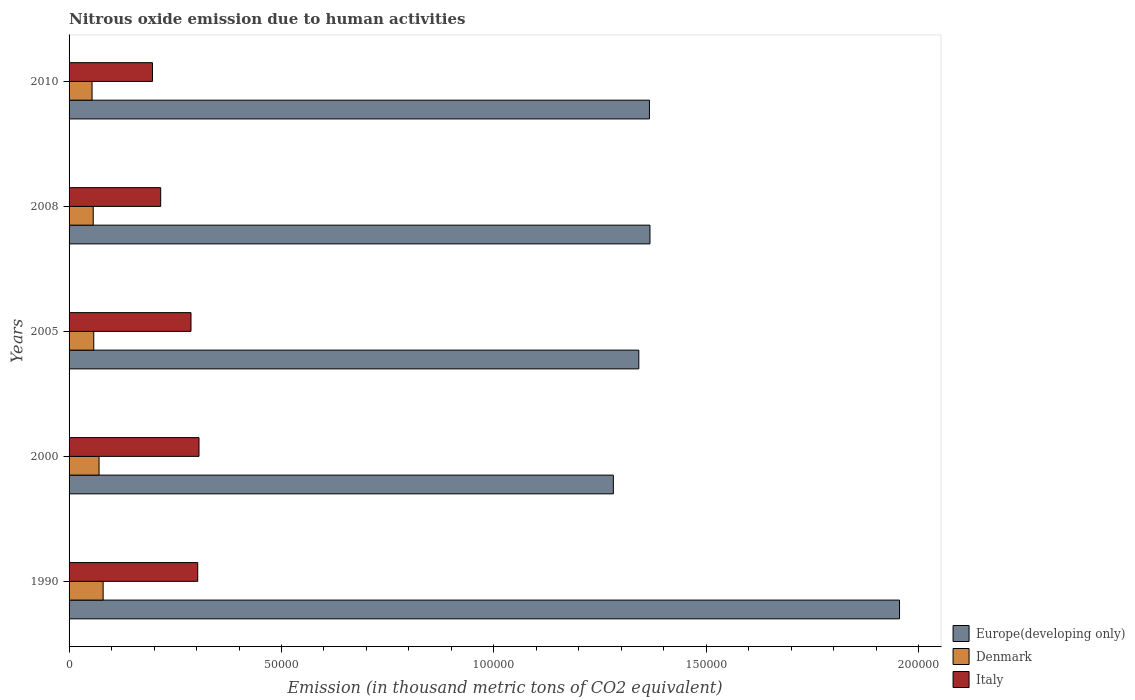How many groups of bars are there?
Your answer should be compact. 5. Are the number of bars per tick equal to the number of legend labels?
Keep it short and to the point. Yes. What is the label of the 2nd group of bars from the top?
Your answer should be compact. 2008. What is the amount of nitrous oxide emitted in Europe(developing only) in 2010?
Provide a short and direct response. 1.37e+05. Across all years, what is the maximum amount of nitrous oxide emitted in Denmark?
Provide a succinct answer. 8017.4. Across all years, what is the minimum amount of nitrous oxide emitted in Denmark?
Provide a short and direct response. 5410. What is the total amount of nitrous oxide emitted in Denmark in the graph?
Offer a very short reply. 3.20e+04. What is the difference between the amount of nitrous oxide emitted in Italy in 1990 and that in 2008?
Give a very brief answer. 8717. What is the difference between the amount of nitrous oxide emitted in Denmark in 2005 and the amount of nitrous oxide emitted in Italy in 2008?
Ensure brevity in your answer.  -1.58e+04. What is the average amount of nitrous oxide emitted in Italy per year?
Keep it short and to the point. 2.62e+04. In the year 2005, what is the difference between the amount of nitrous oxide emitted in Denmark and amount of nitrous oxide emitted in Italy?
Your answer should be compact. -2.29e+04. In how many years, is the amount of nitrous oxide emitted in Denmark greater than 110000 thousand metric tons?
Offer a terse response. 0. What is the ratio of the amount of nitrous oxide emitted in Italy in 2000 to that in 2005?
Offer a terse response. 1.07. Is the amount of nitrous oxide emitted in Italy in 1990 less than that in 2000?
Provide a short and direct response. Yes. Is the difference between the amount of nitrous oxide emitted in Denmark in 2008 and 2010 greater than the difference between the amount of nitrous oxide emitted in Italy in 2008 and 2010?
Give a very brief answer. No. What is the difference between the highest and the second highest amount of nitrous oxide emitted in Italy?
Give a very brief answer. 301.2. What is the difference between the highest and the lowest amount of nitrous oxide emitted in Italy?
Provide a short and direct response. 1.10e+04. In how many years, is the amount of nitrous oxide emitted in Italy greater than the average amount of nitrous oxide emitted in Italy taken over all years?
Your answer should be compact. 3. Is the sum of the amount of nitrous oxide emitted in Europe(developing only) in 1990 and 2000 greater than the maximum amount of nitrous oxide emitted in Denmark across all years?
Your response must be concise. Yes. What does the 1st bar from the bottom in 2008 represents?
Give a very brief answer. Europe(developing only). Is it the case that in every year, the sum of the amount of nitrous oxide emitted in Denmark and amount of nitrous oxide emitted in Italy is greater than the amount of nitrous oxide emitted in Europe(developing only)?
Keep it short and to the point. No. How many bars are there?
Offer a terse response. 15. Are all the bars in the graph horizontal?
Offer a very short reply. Yes. How many years are there in the graph?
Make the answer very short. 5. Where does the legend appear in the graph?
Give a very brief answer. Bottom right. How many legend labels are there?
Provide a succinct answer. 3. How are the legend labels stacked?
Give a very brief answer. Vertical. What is the title of the graph?
Give a very brief answer. Nitrous oxide emission due to human activities. Does "Suriname" appear as one of the legend labels in the graph?
Ensure brevity in your answer.  No. What is the label or title of the X-axis?
Your answer should be very brief. Emission (in thousand metric tons of CO2 equivalent). What is the label or title of the Y-axis?
Your response must be concise. Years. What is the Emission (in thousand metric tons of CO2 equivalent) in Europe(developing only) in 1990?
Offer a very short reply. 1.95e+05. What is the Emission (in thousand metric tons of CO2 equivalent) in Denmark in 1990?
Give a very brief answer. 8017.4. What is the Emission (in thousand metric tons of CO2 equivalent) in Italy in 1990?
Give a very brief answer. 3.03e+04. What is the Emission (in thousand metric tons of CO2 equivalent) in Europe(developing only) in 2000?
Provide a succinct answer. 1.28e+05. What is the Emission (in thousand metric tons of CO2 equivalent) in Denmark in 2000?
Ensure brevity in your answer.  7054.9. What is the Emission (in thousand metric tons of CO2 equivalent) in Italy in 2000?
Provide a succinct answer. 3.06e+04. What is the Emission (in thousand metric tons of CO2 equivalent) in Europe(developing only) in 2005?
Offer a very short reply. 1.34e+05. What is the Emission (in thousand metric tons of CO2 equivalent) of Denmark in 2005?
Make the answer very short. 5813.9. What is the Emission (in thousand metric tons of CO2 equivalent) in Italy in 2005?
Your answer should be very brief. 2.87e+04. What is the Emission (in thousand metric tons of CO2 equivalent) of Europe(developing only) in 2008?
Your answer should be very brief. 1.37e+05. What is the Emission (in thousand metric tons of CO2 equivalent) of Denmark in 2008?
Your answer should be very brief. 5688.2. What is the Emission (in thousand metric tons of CO2 equivalent) of Italy in 2008?
Your answer should be very brief. 2.16e+04. What is the Emission (in thousand metric tons of CO2 equivalent) of Europe(developing only) in 2010?
Offer a terse response. 1.37e+05. What is the Emission (in thousand metric tons of CO2 equivalent) of Denmark in 2010?
Your answer should be very brief. 5410. What is the Emission (in thousand metric tons of CO2 equivalent) of Italy in 2010?
Make the answer very short. 1.96e+04. Across all years, what is the maximum Emission (in thousand metric tons of CO2 equivalent) in Europe(developing only)?
Provide a succinct answer. 1.95e+05. Across all years, what is the maximum Emission (in thousand metric tons of CO2 equivalent) in Denmark?
Ensure brevity in your answer.  8017.4. Across all years, what is the maximum Emission (in thousand metric tons of CO2 equivalent) in Italy?
Provide a succinct answer. 3.06e+04. Across all years, what is the minimum Emission (in thousand metric tons of CO2 equivalent) in Europe(developing only)?
Provide a short and direct response. 1.28e+05. Across all years, what is the minimum Emission (in thousand metric tons of CO2 equivalent) in Denmark?
Your response must be concise. 5410. Across all years, what is the minimum Emission (in thousand metric tons of CO2 equivalent) in Italy?
Your answer should be very brief. 1.96e+04. What is the total Emission (in thousand metric tons of CO2 equivalent) in Europe(developing only) in the graph?
Your answer should be very brief. 7.31e+05. What is the total Emission (in thousand metric tons of CO2 equivalent) of Denmark in the graph?
Keep it short and to the point. 3.20e+04. What is the total Emission (in thousand metric tons of CO2 equivalent) of Italy in the graph?
Offer a terse response. 1.31e+05. What is the difference between the Emission (in thousand metric tons of CO2 equivalent) in Europe(developing only) in 1990 and that in 2000?
Your response must be concise. 6.74e+04. What is the difference between the Emission (in thousand metric tons of CO2 equivalent) in Denmark in 1990 and that in 2000?
Give a very brief answer. 962.5. What is the difference between the Emission (in thousand metric tons of CO2 equivalent) in Italy in 1990 and that in 2000?
Make the answer very short. -301.2. What is the difference between the Emission (in thousand metric tons of CO2 equivalent) in Europe(developing only) in 1990 and that in 2005?
Offer a very short reply. 6.14e+04. What is the difference between the Emission (in thousand metric tons of CO2 equivalent) of Denmark in 1990 and that in 2005?
Make the answer very short. 2203.5. What is the difference between the Emission (in thousand metric tons of CO2 equivalent) of Italy in 1990 and that in 2005?
Provide a short and direct response. 1584.9. What is the difference between the Emission (in thousand metric tons of CO2 equivalent) in Europe(developing only) in 1990 and that in 2008?
Keep it short and to the point. 5.87e+04. What is the difference between the Emission (in thousand metric tons of CO2 equivalent) in Denmark in 1990 and that in 2008?
Keep it short and to the point. 2329.2. What is the difference between the Emission (in thousand metric tons of CO2 equivalent) of Italy in 1990 and that in 2008?
Make the answer very short. 8717. What is the difference between the Emission (in thousand metric tons of CO2 equivalent) in Europe(developing only) in 1990 and that in 2010?
Offer a terse response. 5.89e+04. What is the difference between the Emission (in thousand metric tons of CO2 equivalent) of Denmark in 1990 and that in 2010?
Ensure brevity in your answer.  2607.4. What is the difference between the Emission (in thousand metric tons of CO2 equivalent) in Italy in 1990 and that in 2010?
Provide a succinct answer. 1.07e+04. What is the difference between the Emission (in thousand metric tons of CO2 equivalent) of Europe(developing only) in 2000 and that in 2005?
Provide a succinct answer. -5992.3. What is the difference between the Emission (in thousand metric tons of CO2 equivalent) in Denmark in 2000 and that in 2005?
Your answer should be very brief. 1241. What is the difference between the Emission (in thousand metric tons of CO2 equivalent) of Italy in 2000 and that in 2005?
Provide a succinct answer. 1886.1. What is the difference between the Emission (in thousand metric tons of CO2 equivalent) in Europe(developing only) in 2000 and that in 2008?
Your answer should be very brief. -8618.7. What is the difference between the Emission (in thousand metric tons of CO2 equivalent) of Denmark in 2000 and that in 2008?
Keep it short and to the point. 1366.7. What is the difference between the Emission (in thousand metric tons of CO2 equivalent) in Italy in 2000 and that in 2008?
Offer a terse response. 9018.2. What is the difference between the Emission (in thousand metric tons of CO2 equivalent) in Europe(developing only) in 2000 and that in 2010?
Offer a very short reply. -8495.7. What is the difference between the Emission (in thousand metric tons of CO2 equivalent) in Denmark in 2000 and that in 2010?
Make the answer very short. 1644.9. What is the difference between the Emission (in thousand metric tons of CO2 equivalent) in Italy in 2000 and that in 2010?
Offer a terse response. 1.10e+04. What is the difference between the Emission (in thousand metric tons of CO2 equivalent) of Europe(developing only) in 2005 and that in 2008?
Offer a very short reply. -2626.4. What is the difference between the Emission (in thousand metric tons of CO2 equivalent) in Denmark in 2005 and that in 2008?
Make the answer very short. 125.7. What is the difference between the Emission (in thousand metric tons of CO2 equivalent) in Italy in 2005 and that in 2008?
Your answer should be very brief. 7132.1. What is the difference between the Emission (in thousand metric tons of CO2 equivalent) in Europe(developing only) in 2005 and that in 2010?
Keep it short and to the point. -2503.4. What is the difference between the Emission (in thousand metric tons of CO2 equivalent) in Denmark in 2005 and that in 2010?
Make the answer very short. 403.9. What is the difference between the Emission (in thousand metric tons of CO2 equivalent) in Italy in 2005 and that in 2010?
Your answer should be compact. 9065.9. What is the difference between the Emission (in thousand metric tons of CO2 equivalent) in Europe(developing only) in 2008 and that in 2010?
Provide a succinct answer. 123. What is the difference between the Emission (in thousand metric tons of CO2 equivalent) in Denmark in 2008 and that in 2010?
Your response must be concise. 278.2. What is the difference between the Emission (in thousand metric tons of CO2 equivalent) of Italy in 2008 and that in 2010?
Provide a succinct answer. 1933.8. What is the difference between the Emission (in thousand metric tons of CO2 equivalent) in Europe(developing only) in 1990 and the Emission (in thousand metric tons of CO2 equivalent) in Denmark in 2000?
Offer a very short reply. 1.88e+05. What is the difference between the Emission (in thousand metric tons of CO2 equivalent) in Europe(developing only) in 1990 and the Emission (in thousand metric tons of CO2 equivalent) in Italy in 2000?
Offer a terse response. 1.65e+05. What is the difference between the Emission (in thousand metric tons of CO2 equivalent) in Denmark in 1990 and the Emission (in thousand metric tons of CO2 equivalent) in Italy in 2000?
Your answer should be compact. -2.26e+04. What is the difference between the Emission (in thousand metric tons of CO2 equivalent) in Europe(developing only) in 1990 and the Emission (in thousand metric tons of CO2 equivalent) in Denmark in 2005?
Provide a succinct answer. 1.90e+05. What is the difference between the Emission (in thousand metric tons of CO2 equivalent) of Europe(developing only) in 1990 and the Emission (in thousand metric tons of CO2 equivalent) of Italy in 2005?
Offer a very short reply. 1.67e+05. What is the difference between the Emission (in thousand metric tons of CO2 equivalent) in Denmark in 1990 and the Emission (in thousand metric tons of CO2 equivalent) in Italy in 2005?
Provide a succinct answer. -2.07e+04. What is the difference between the Emission (in thousand metric tons of CO2 equivalent) of Europe(developing only) in 1990 and the Emission (in thousand metric tons of CO2 equivalent) of Denmark in 2008?
Offer a terse response. 1.90e+05. What is the difference between the Emission (in thousand metric tons of CO2 equivalent) of Europe(developing only) in 1990 and the Emission (in thousand metric tons of CO2 equivalent) of Italy in 2008?
Ensure brevity in your answer.  1.74e+05. What is the difference between the Emission (in thousand metric tons of CO2 equivalent) in Denmark in 1990 and the Emission (in thousand metric tons of CO2 equivalent) in Italy in 2008?
Offer a very short reply. -1.35e+04. What is the difference between the Emission (in thousand metric tons of CO2 equivalent) in Europe(developing only) in 1990 and the Emission (in thousand metric tons of CO2 equivalent) in Denmark in 2010?
Give a very brief answer. 1.90e+05. What is the difference between the Emission (in thousand metric tons of CO2 equivalent) of Europe(developing only) in 1990 and the Emission (in thousand metric tons of CO2 equivalent) of Italy in 2010?
Give a very brief answer. 1.76e+05. What is the difference between the Emission (in thousand metric tons of CO2 equivalent) in Denmark in 1990 and the Emission (in thousand metric tons of CO2 equivalent) in Italy in 2010?
Keep it short and to the point. -1.16e+04. What is the difference between the Emission (in thousand metric tons of CO2 equivalent) in Europe(developing only) in 2000 and the Emission (in thousand metric tons of CO2 equivalent) in Denmark in 2005?
Offer a terse response. 1.22e+05. What is the difference between the Emission (in thousand metric tons of CO2 equivalent) in Europe(developing only) in 2000 and the Emission (in thousand metric tons of CO2 equivalent) in Italy in 2005?
Make the answer very short. 9.94e+04. What is the difference between the Emission (in thousand metric tons of CO2 equivalent) in Denmark in 2000 and the Emission (in thousand metric tons of CO2 equivalent) in Italy in 2005?
Your response must be concise. -2.16e+04. What is the difference between the Emission (in thousand metric tons of CO2 equivalent) of Europe(developing only) in 2000 and the Emission (in thousand metric tons of CO2 equivalent) of Denmark in 2008?
Your response must be concise. 1.22e+05. What is the difference between the Emission (in thousand metric tons of CO2 equivalent) in Europe(developing only) in 2000 and the Emission (in thousand metric tons of CO2 equivalent) in Italy in 2008?
Make the answer very short. 1.07e+05. What is the difference between the Emission (in thousand metric tons of CO2 equivalent) in Denmark in 2000 and the Emission (in thousand metric tons of CO2 equivalent) in Italy in 2008?
Your response must be concise. -1.45e+04. What is the difference between the Emission (in thousand metric tons of CO2 equivalent) in Europe(developing only) in 2000 and the Emission (in thousand metric tons of CO2 equivalent) in Denmark in 2010?
Your response must be concise. 1.23e+05. What is the difference between the Emission (in thousand metric tons of CO2 equivalent) of Europe(developing only) in 2000 and the Emission (in thousand metric tons of CO2 equivalent) of Italy in 2010?
Keep it short and to the point. 1.08e+05. What is the difference between the Emission (in thousand metric tons of CO2 equivalent) of Denmark in 2000 and the Emission (in thousand metric tons of CO2 equivalent) of Italy in 2010?
Give a very brief answer. -1.26e+04. What is the difference between the Emission (in thousand metric tons of CO2 equivalent) in Europe(developing only) in 2005 and the Emission (in thousand metric tons of CO2 equivalent) in Denmark in 2008?
Provide a succinct answer. 1.28e+05. What is the difference between the Emission (in thousand metric tons of CO2 equivalent) in Europe(developing only) in 2005 and the Emission (in thousand metric tons of CO2 equivalent) in Italy in 2008?
Provide a succinct answer. 1.13e+05. What is the difference between the Emission (in thousand metric tons of CO2 equivalent) of Denmark in 2005 and the Emission (in thousand metric tons of CO2 equivalent) of Italy in 2008?
Provide a succinct answer. -1.58e+04. What is the difference between the Emission (in thousand metric tons of CO2 equivalent) in Europe(developing only) in 2005 and the Emission (in thousand metric tons of CO2 equivalent) in Denmark in 2010?
Offer a terse response. 1.29e+05. What is the difference between the Emission (in thousand metric tons of CO2 equivalent) of Europe(developing only) in 2005 and the Emission (in thousand metric tons of CO2 equivalent) of Italy in 2010?
Make the answer very short. 1.14e+05. What is the difference between the Emission (in thousand metric tons of CO2 equivalent) in Denmark in 2005 and the Emission (in thousand metric tons of CO2 equivalent) in Italy in 2010?
Offer a very short reply. -1.38e+04. What is the difference between the Emission (in thousand metric tons of CO2 equivalent) in Europe(developing only) in 2008 and the Emission (in thousand metric tons of CO2 equivalent) in Denmark in 2010?
Make the answer very short. 1.31e+05. What is the difference between the Emission (in thousand metric tons of CO2 equivalent) of Europe(developing only) in 2008 and the Emission (in thousand metric tons of CO2 equivalent) of Italy in 2010?
Your answer should be compact. 1.17e+05. What is the difference between the Emission (in thousand metric tons of CO2 equivalent) of Denmark in 2008 and the Emission (in thousand metric tons of CO2 equivalent) of Italy in 2010?
Your response must be concise. -1.39e+04. What is the average Emission (in thousand metric tons of CO2 equivalent) of Europe(developing only) per year?
Make the answer very short. 1.46e+05. What is the average Emission (in thousand metric tons of CO2 equivalent) in Denmark per year?
Keep it short and to the point. 6396.88. What is the average Emission (in thousand metric tons of CO2 equivalent) in Italy per year?
Make the answer very short. 2.62e+04. In the year 1990, what is the difference between the Emission (in thousand metric tons of CO2 equivalent) of Europe(developing only) and Emission (in thousand metric tons of CO2 equivalent) of Denmark?
Your response must be concise. 1.87e+05. In the year 1990, what is the difference between the Emission (in thousand metric tons of CO2 equivalent) of Europe(developing only) and Emission (in thousand metric tons of CO2 equivalent) of Italy?
Your response must be concise. 1.65e+05. In the year 1990, what is the difference between the Emission (in thousand metric tons of CO2 equivalent) of Denmark and Emission (in thousand metric tons of CO2 equivalent) of Italy?
Provide a succinct answer. -2.23e+04. In the year 2000, what is the difference between the Emission (in thousand metric tons of CO2 equivalent) of Europe(developing only) and Emission (in thousand metric tons of CO2 equivalent) of Denmark?
Ensure brevity in your answer.  1.21e+05. In the year 2000, what is the difference between the Emission (in thousand metric tons of CO2 equivalent) in Europe(developing only) and Emission (in thousand metric tons of CO2 equivalent) in Italy?
Give a very brief answer. 9.75e+04. In the year 2000, what is the difference between the Emission (in thousand metric tons of CO2 equivalent) in Denmark and Emission (in thousand metric tons of CO2 equivalent) in Italy?
Make the answer very short. -2.35e+04. In the year 2005, what is the difference between the Emission (in thousand metric tons of CO2 equivalent) in Europe(developing only) and Emission (in thousand metric tons of CO2 equivalent) in Denmark?
Provide a succinct answer. 1.28e+05. In the year 2005, what is the difference between the Emission (in thousand metric tons of CO2 equivalent) in Europe(developing only) and Emission (in thousand metric tons of CO2 equivalent) in Italy?
Give a very brief answer. 1.05e+05. In the year 2005, what is the difference between the Emission (in thousand metric tons of CO2 equivalent) of Denmark and Emission (in thousand metric tons of CO2 equivalent) of Italy?
Provide a short and direct response. -2.29e+04. In the year 2008, what is the difference between the Emission (in thousand metric tons of CO2 equivalent) of Europe(developing only) and Emission (in thousand metric tons of CO2 equivalent) of Denmark?
Keep it short and to the point. 1.31e+05. In the year 2008, what is the difference between the Emission (in thousand metric tons of CO2 equivalent) in Europe(developing only) and Emission (in thousand metric tons of CO2 equivalent) in Italy?
Your answer should be compact. 1.15e+05. In the year 2008, what is the difference between the Emission (in thousand metric tons of CO2 equivalent) in Denmark and Emission (in thousand metric tons of CO2 equivalent) in Italy?
Offer a very short reply. -1.59e+04. In the year 2010, what is the difference between the Emission (in thousand metric tons of CO2 equivalent) of Europe(developing only) and Emission (in thousand metric tons of CO2 equivalent) of Denmark?
Your answer should be compact. 1.31e+05. In the year 2010, what is the difference between the Emission (in thousand metric tons of CO2 equivalent) in Europe(developing only) and Emission (in thousand metric tons of CO2 equivalent) in Italy?
Your answer should be compact. 1.17e+05. In the year 2010, what is the difference between the Emission (in thousand metric tons of CO2 equivalent) of Denmark and Emission (in thousand metric tons of CO2 equivalent) of Italy?
Your response must be concise. -1.42e+04. What is the ratio of the Emission (in thousand metric tons of CO2 equivalent) of Europe(developing only) in 1990 to that in 2000?
Offer a very short reply. 1.53. What is the ratio of the Emission (in thousand metric tons of CO2 equivalent) of Denmark in 1990 to that in 2000?
Your answer should be compact. 1.14. What is the ratio of the Emission (in thousand metric tons of CO2 equivalent) in Italy in 1990 to that in 2000?
Your response must be concise. 0.99. What is the ratio of the Emission (in thousand metric tons of CO2 equivalent) in Europe(developing only) in 1990 to that in 2005?
Your response must be concise. 1.46. What is the ratio of the Emission (in thousand metric tons of CO2 equivalent) of Denmark in 1990 to that in 2005?
Provide a short and direct response. 1.38. What is the ratio of the Emission (in thousand metric tons of CO2 equivalent) in Italy in 1990 to that in 2005?
Provide a succinct answer. 1.06. What is the ratio of the Emission (in thousand metric tons of CO2 equivalent) in Europe(developing only) in 1990 to that in 2008?
Offer a very short reply. 1.43. What is the ratio of the Emission (in thousand metric tons of CO2 equivalent) of Denmark in 1990 to that in 2008?
Provide a short and direct response. 1.41. What is the ratio of the Emission (in thousand metric tons of CO2 equivalent) of Italy in 1990 to that in 2008?
Your response must be concise. 1.4. What is the ratio of the Emission (in thousand metric tons of CO2 equivalent) in Europe(developing only) in 1990 to that in 2010?
Offer a terse response. 1.43. What is the ratio of the Emission (in thousand metric tons of CO2 equivalent) in Denmark in 1990 to that in 2010?
Your answer should be compact. 1.48. What is the ratio of the Emission (in thousand metric tons of CO2 equivalent) of Italy in 1990 to that in 2010?
Keep it short and to the point. 1.54. What is the ratio of the Emission (in thousand metric tons of CO2 equivalent) of Europe(developing only) in 2000 to that in 2005?
Your answer should be compact. 0.96. What is the ratio of the Emission (in thousand metric tons of CO2 equivalent) of Denmark in 2000 to that in 2005?
Provide a short and direct response. 1.21. What is the ratio of the Emission (in thousand metric tons of CO2 equivalent) in Italy in 2000 to that in 2005?
Your answer should be compact. 1.07. What is the ratio of the Emission (in thousand metric tons of CO2 equivalent) in Europe(developing only) in 2000 to that in 2008?
Your response must be concise. 0.94. What is the ratio of the Emission (in thousand metric tons of CO2 equivalent) of Denmark in 2000 to that in 2008?
Your response must be concise. 1.24. What is the ratio of the Emission (in thousand metric tons of CO2 equivalent) in Italy in 2000 to that in 2008?
Give a very brief answer. 1.42. What is the ratio of the Emission (in thousand metric tons of CO2 equivalent) of Europe(developing only) in 2000 to that in 2010?
Offer a terse response. 0.94. What is the ratio of the Emission (in thousand metric tons of CO2 equivalent) in Denmark in 2000 to that in 2010?
Offer a terse response. 1.3. What is the ratio of the Emission (in thousand metric tons of CO2 equivalent) of Italy in 2000 to that in 2010?
Your answer should be compact. 1.56. What is the ratio of the Emission (in thousand metric tons of CO2 equivalent) in Europe(developing only) in 2005 to that in 2008?
Offer a very short reply. 0.98. What is the ratio of the Emission (in thousand metric tons of CO2 equivalent) in Denmark in 2005 to that in 2008?
Give a very brief answer. 1.02. What is the ratio of the Emission (in thousand metric tons of CO2 equivalent) of Italy in 2005 to that in 2008?
Ensure brevity in your answer.  1.33. What is the ratio of the Emission (in thousand metric tons of CO2 equivalent) in Europe(developing only) in 2005 to that in 2010?
Give a very brief answer. 0.98. What is the ratio of the Emission (in thousand metric tons of CO2 equivalent) of Denmark in 2005 to that in 2010?
Make the answer very short. 1.07. What is the ratio of the Emission (in thousand metric tons of CO2 equivalent) of Italy in 2005 to that in 2010?
Provide a succinct answer. 1.46. What is the ratio of the Emission (in thousand metric tons of CO2 equivalent) of Europe(developing only) in 2008 to that in 2010?
Offer a terse response. 1. What is the ratio of the Emission (in thousand metric tons of CO2 equivalent) in Denmark in 2008 to that in 2010?
Provide a short and direct response. 1.05. What is the ratio of the Emission (in thousand metric tons of CO2 equivalent) in Italy in 2008 to that in 2010?
Offer a terse response. 1.1. What is the difference between the highest and the second highest Emission (in thousand metric tons of CO2 equivalent) in Europe(developing only)?
Offer a terse response. 5.87e+04. What is the difference between the highest and the second highest Emission (in thousand metric tons of CO2 equivalent) in Denmark?
Your response must be concise. 962.5. What is the difference between the highest and the second highest Emission (in thousand metric tons of CO2 equivalent) of Italy?
Offer a terse response. 301.2. What is the difference between the highest and the lowest Emission (in thousand metric tons of CO2 equivalent) of Europe(developing only)?
Offer a very short reply. 6.74e+04. What is the difference between the highest and the lowest Emission (in thousand metric tons of CO2 equivalent) of Denmark?
Your answer should be compact. 2607.4. What is the difference between the highest and the lowest Emission (in thousand metric tons of CO2 equivalent) of Italy?
Keep it short and to the point. 1.10e+04. 